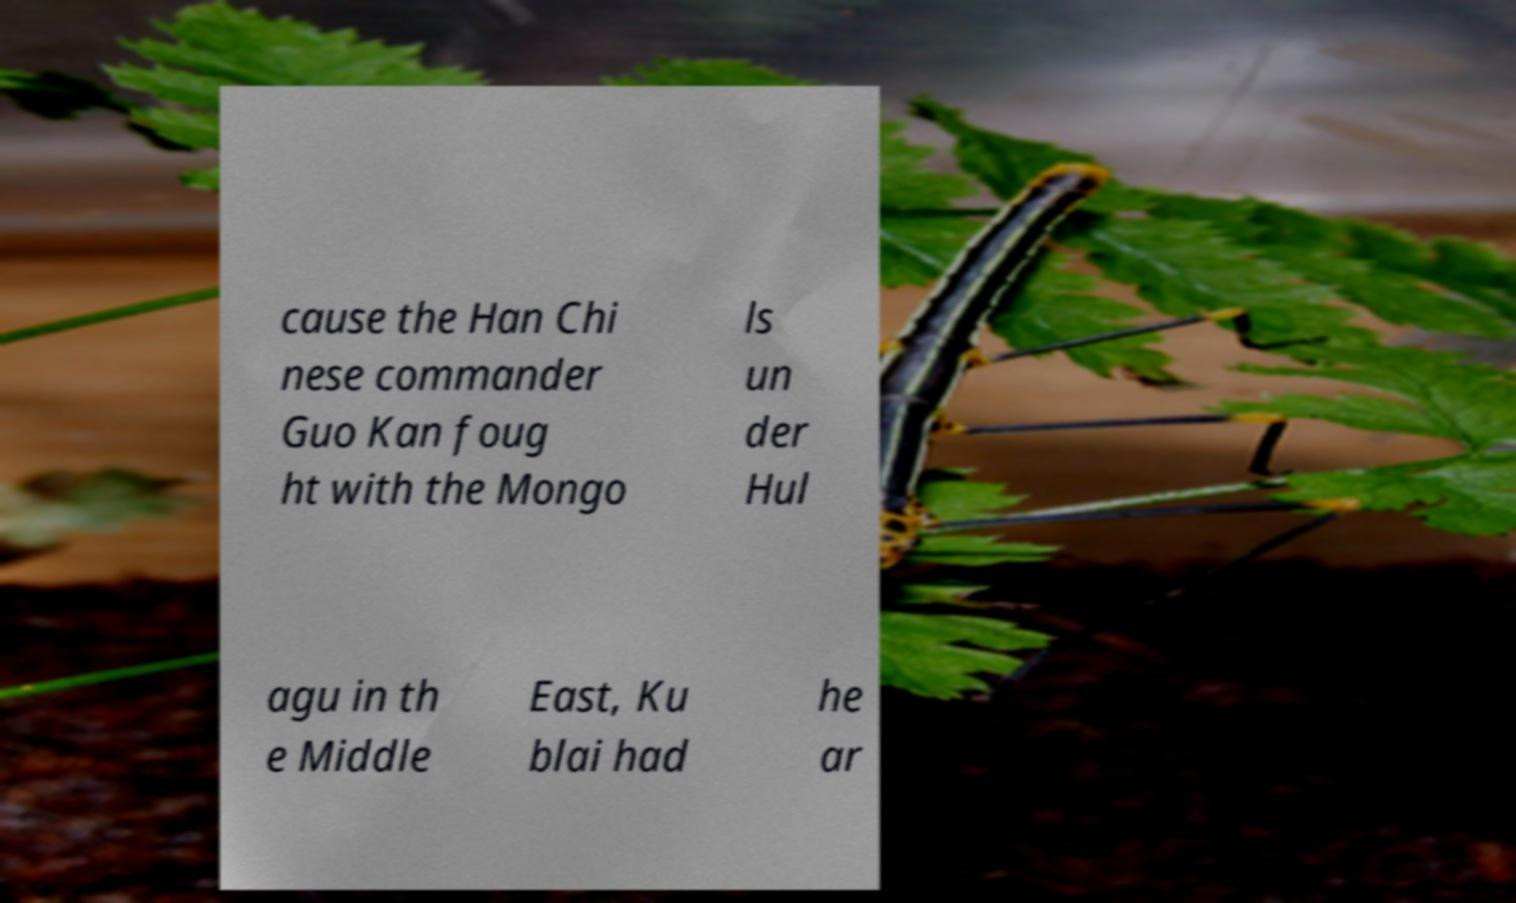Could you assist in decoding the text presented in this image and type it out clearly? cause the Han Chi nese commander Guo Kan foug ht with the Mongo ls un der Hul agu in th e Middle East, Ku blai had he ar 